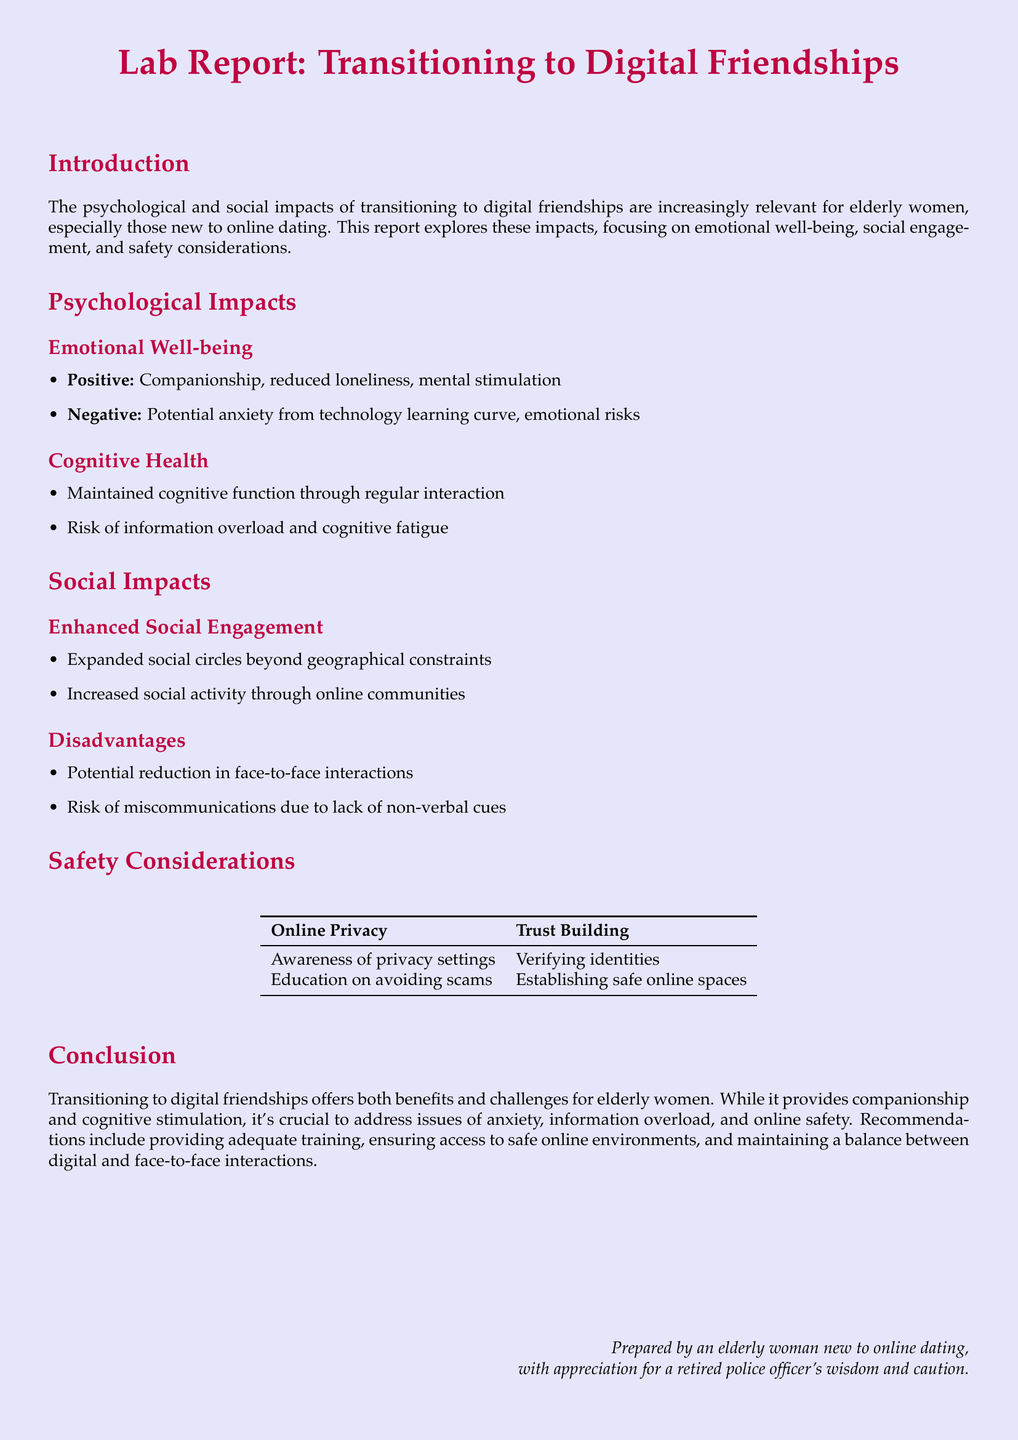What are the positive psychological impacts mentioned? The document lists companionship, reduced loneliness, and mental stimulation as positive impacts.
Answer: companionship, reduced loneliness, mental stimulation What is a negative psychological impact identified? The report states that potential anxiety from the technology learning curve is a negative impact.
Answer: potential anxiety What is one advantage of enhanced social engagement? The document highlights that it allows for expanded social circles beyond geographical constraints.
Answer: expanded social circles What is a disadvantage of digital friendships mentioned? The report notes the potential reduction in face-to-face interactions as a disadvantage.
Answer: reduction in face-to-face interactions What are two components of safety considerations? The table includes awareness of privacy settings and verifying identities as components of safety.
Answer: awareness of privacy settings, verifying identities What is a recommendation made in the conclusion? The report recommends providing adequate training to ensure safety in online interactions.
Answer: providing adequate training How does the report suggest maintaining cognitive health? Regular interaction is suggested as a way to maintain cognitive health.
Answer: regular interaction What social activity is increased according to the document? The report mentions increased social activity through online communities.
Answer: increased social activity What is one risk associated with cognitive health? The report highlights the risk of information overload as a concern for cognitive health.
Answer: information overload 